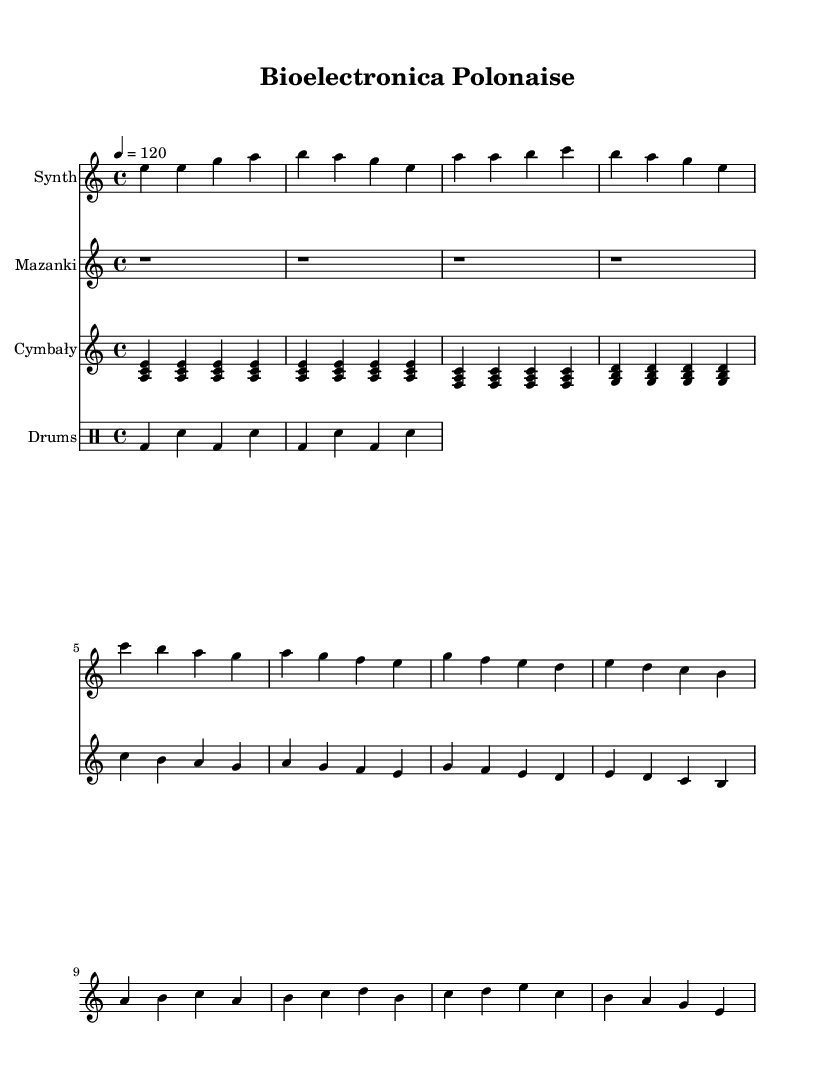What is the key signature of this music? The key signature shown in the sheet music indicates that it is in A minor, which has no sharps or flats.
Answer: A minor What is the time signature of the music? The time signature in this sheet music is 4/4, which means there are four beats in each measure and the quarter note gets one beat.
Answer: 4/4 What is the tempo marking for this piece? The tempo marking indicates that the piece should be played at a speed of 120 beats per minute, as shown in the tempo indication.
Answer: 120 How many measures are in the synthesizer part? By counting the measures in the synthesizer notation, there are a total of 12 measures shown.
Answer: 12 What type of traditional instrument is represented in this music? The music features 'cymbały', which is a traditional Polish instrument similar to a dulcimer and contributes to the fusion of electronic and traditional sounds.
Answer: Cymbały What rhythmic pattern is used in the drum section? The drum pattern consists of bass drum (bd) and snare (sn) arranged in a repeating four-note sequence, adding to the electronic feel.
Answer: Bass and snare What is the first note played by the 'mazanki' instrument? The first note in the mazanki part is a rest, indicating no sound should be produced during the first measure.
Answer: Rest 